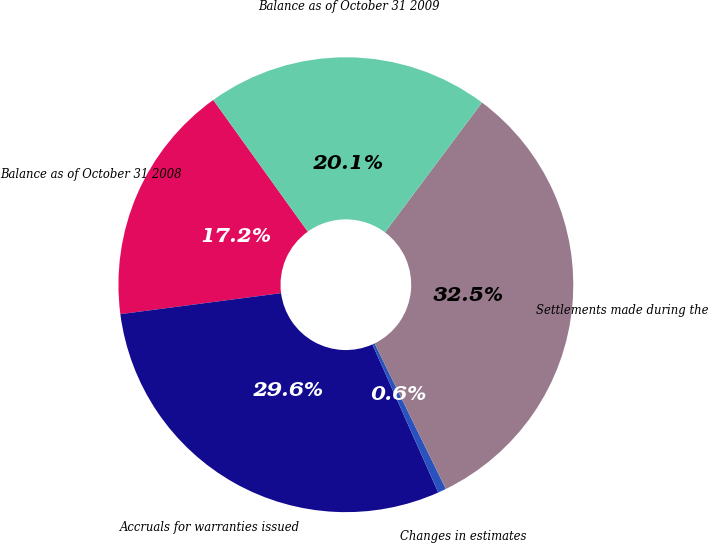<chart> <loc_0><loc_0><loc_500><loc_500><pie_chart><fcel>Balance as of October 31 2008<fcel>Accruals for warranties issued<fcel>Changes in estimates<fcel>Settlements made during the<fcel>Balance as of October 31 2009<nl><fcel>17.16%<fcel>29.59%<fcel>0.59%<fcel>32.54%<fcel>20.12%<nl></chart> 